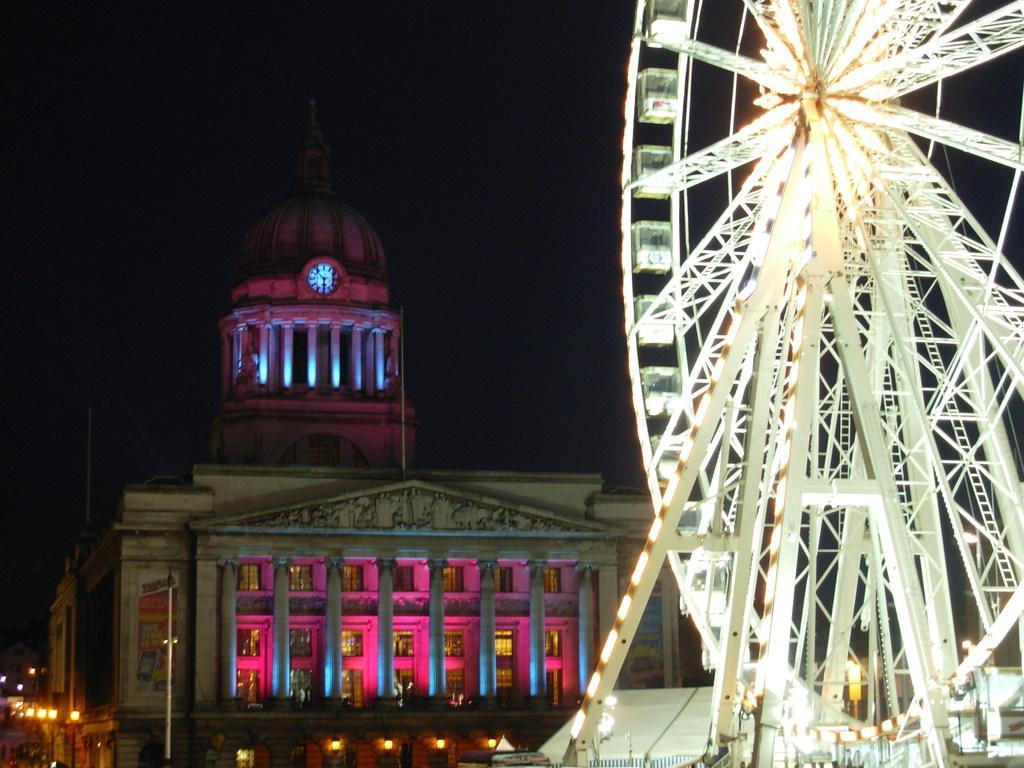Describe this image in one or two sentences. In this picture I can observe a giant wheel on the right side. In the background I can observe a building and sky which is completely dark. 